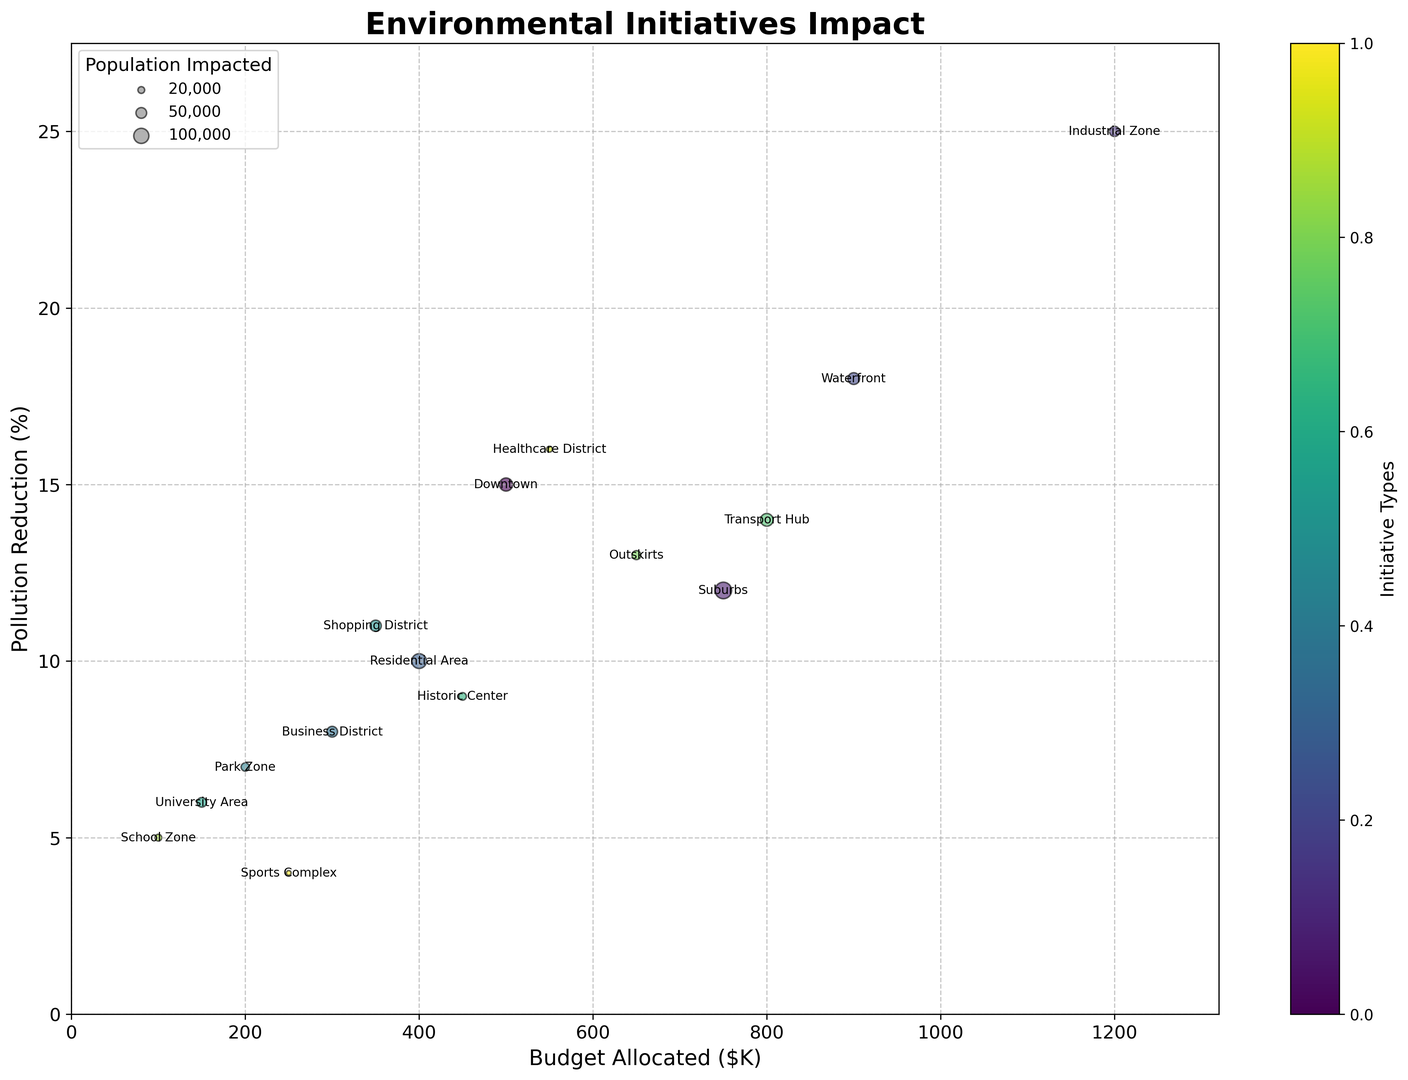Which city area achieved the highest pollution reduction, and what percentage was achieved? The area with the highest pollution reduction is identified by the highest point on the y-axis. The Industrial Zone achieved a 25% reduction.
Answer: Industrial Zone, 25% Compare the budgets allocated to Green Spaces and Solar Panels initiatives. Which one is higher and by how much? Green Spaces in Downtown and Solar Panels in Suburbs can be compared by looking at their values on the x-axis. Solar Panels have a budget of $750K, and Green Spaces have a budget of $500K, so the difference is $750K - $500K = $250K, with Solar Panels being higher.
Answer: Solar Panels, $250K What is the combined pollution reduction achieved by Bike Lanes and Environmental Education initiatives? Sum the Pollution Reduction percentages of Bike Lanes (6%) and Environmental Education (5%) to find the total combined reduction: 6% + 5% = 11%.
Answer: 11% Which initiatives impact the largest and smallest populations, and what are their corresponding population sizes? To identify which initiatives impact the largest and smallest populations, observe the sizes of the bubbles. The Solar Panels initiative in Suburbs impacts the largest population (120,000), and the Sustainable Facilities initiative in Sports Complex impacts the smallest population (10,000).
Answer: Solar Panels, 120,000; Sustainable Facilities, 10,000 What are the three highest budgets allocated to initiatives, and which areas do they correspond to? By examining the x-axis, the three highest budget values are for Waste Management ($1200K), Water Treatment ($900K), and Low Emission Buses ($800K). These correspond to the Industrial Zone, Waterfront, and Transport Hub, respectively.
Answer: Industrial Zone ($1200K), Waterfront ($900K), Transport Hub ($800K) Between Low Emission Buses and Water Treatment initiatives, which one had a higher pollution reduction and by how much? Compare the y-axis values for Low Emission Buses (14%) and Water Treatment (18%). Water Treatment had a higher pollution reduction by 18% - 14% = 4%.
Answer: Water Treatment, 4% Does the initiative with the highest budget also achieve the highest pollution reduction? The highest budget is allocated to Waste Management in the Industrial Zone with $1200K, which also achieves the highest pollution reduction of 25%.
Answer: Yes Which city area has a higher pollution reduction: Downtown or Business District? Compare the y-axis values for Downtown (Green Spaces, 15%) and Business District (Electric Vehicle Charging, 8%). Downtown has a higher pollution reduction of 15% compared to 8%.
Answer: Downtown How many initiatives have a budget greater than $500K? Count the number of points on the x-axis that are to the right of the $500K mark. The initiatives exceeding $500K budgets are Solar Panels, Waste Management, Water Treatment, Low Emission Buses, Wind Turbines, and Medical Waste Management. There are 6 such initiatives.
Answer: 6 What is the pollution reduction range observed within the different initiatives? The range is determined by the highest and lowest points on the y-axis. The highest reduction is 25% (Industrial Zone), and the lowest is 4% (Sports Complex). The range is 25% - 4% = 21%.
Answer: 21% 